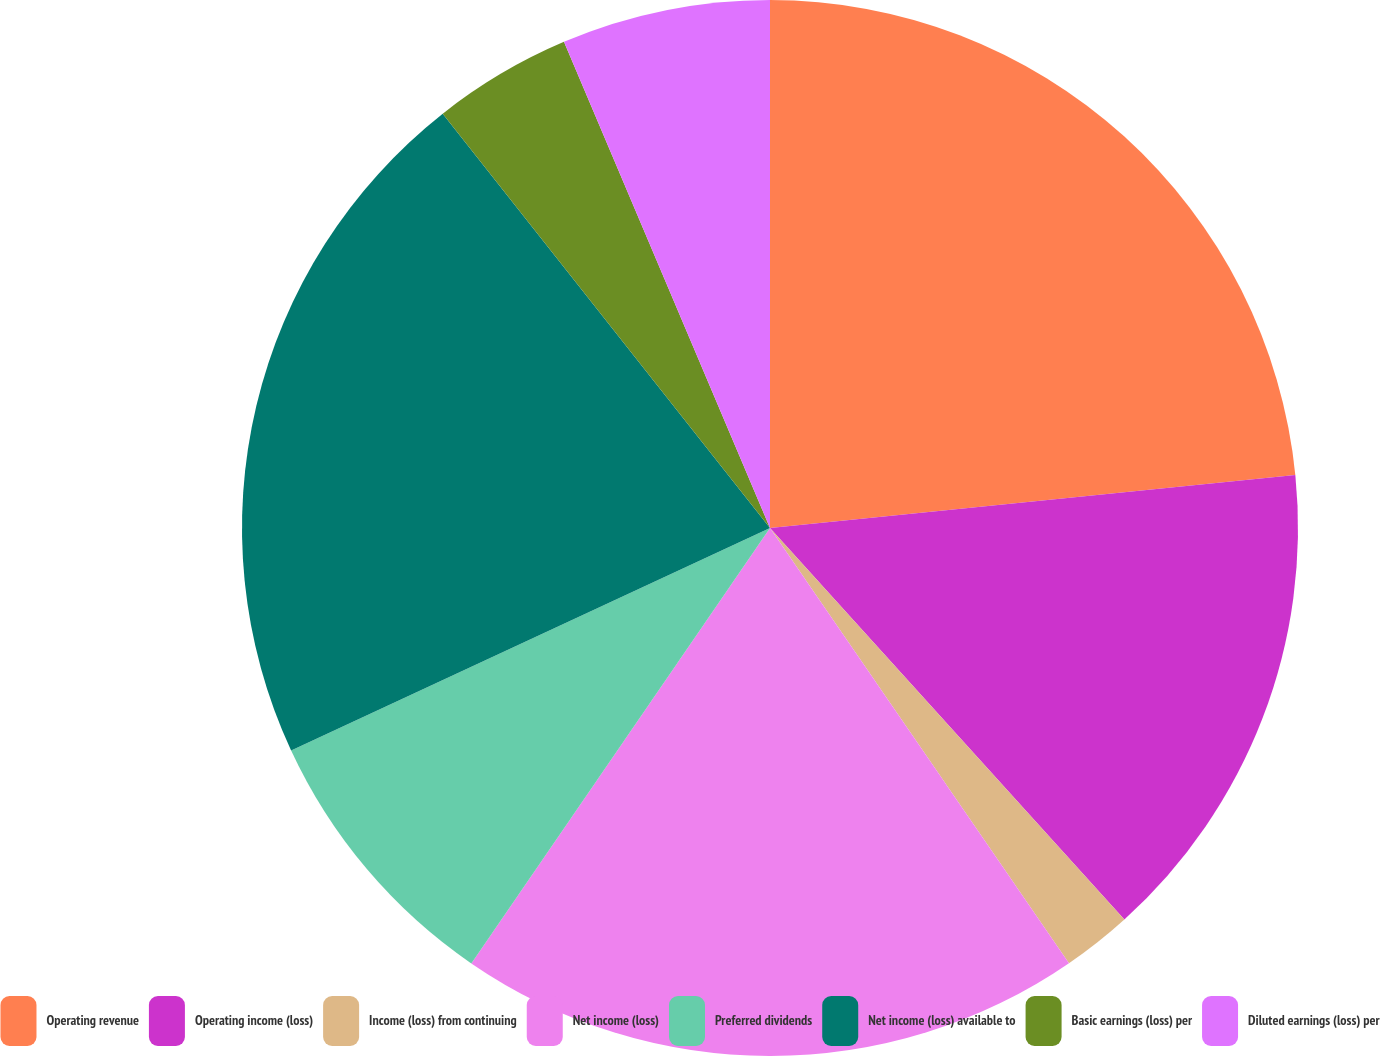<chart> <loc_0><loc_0><loc_500><loc_500><pie_chart><fcel>Operating revenue<fcel>Operating income (loss)<fcel>Income (loss) from continuing<fcel>Net income (loss)<fcel>Preferred dividends<fcel>Net income (loss) available to<fcel>Basic earnings (loss) per<fcel>Diluted earnings (loss) per<nl><fcel>23.4%<fcel>14.89%<fcel>2.13%<fcel>19.15%<fcel>8.51%<fcel>21.28%<fcel>4.26%<fcel>6.38%<nl></chart> 